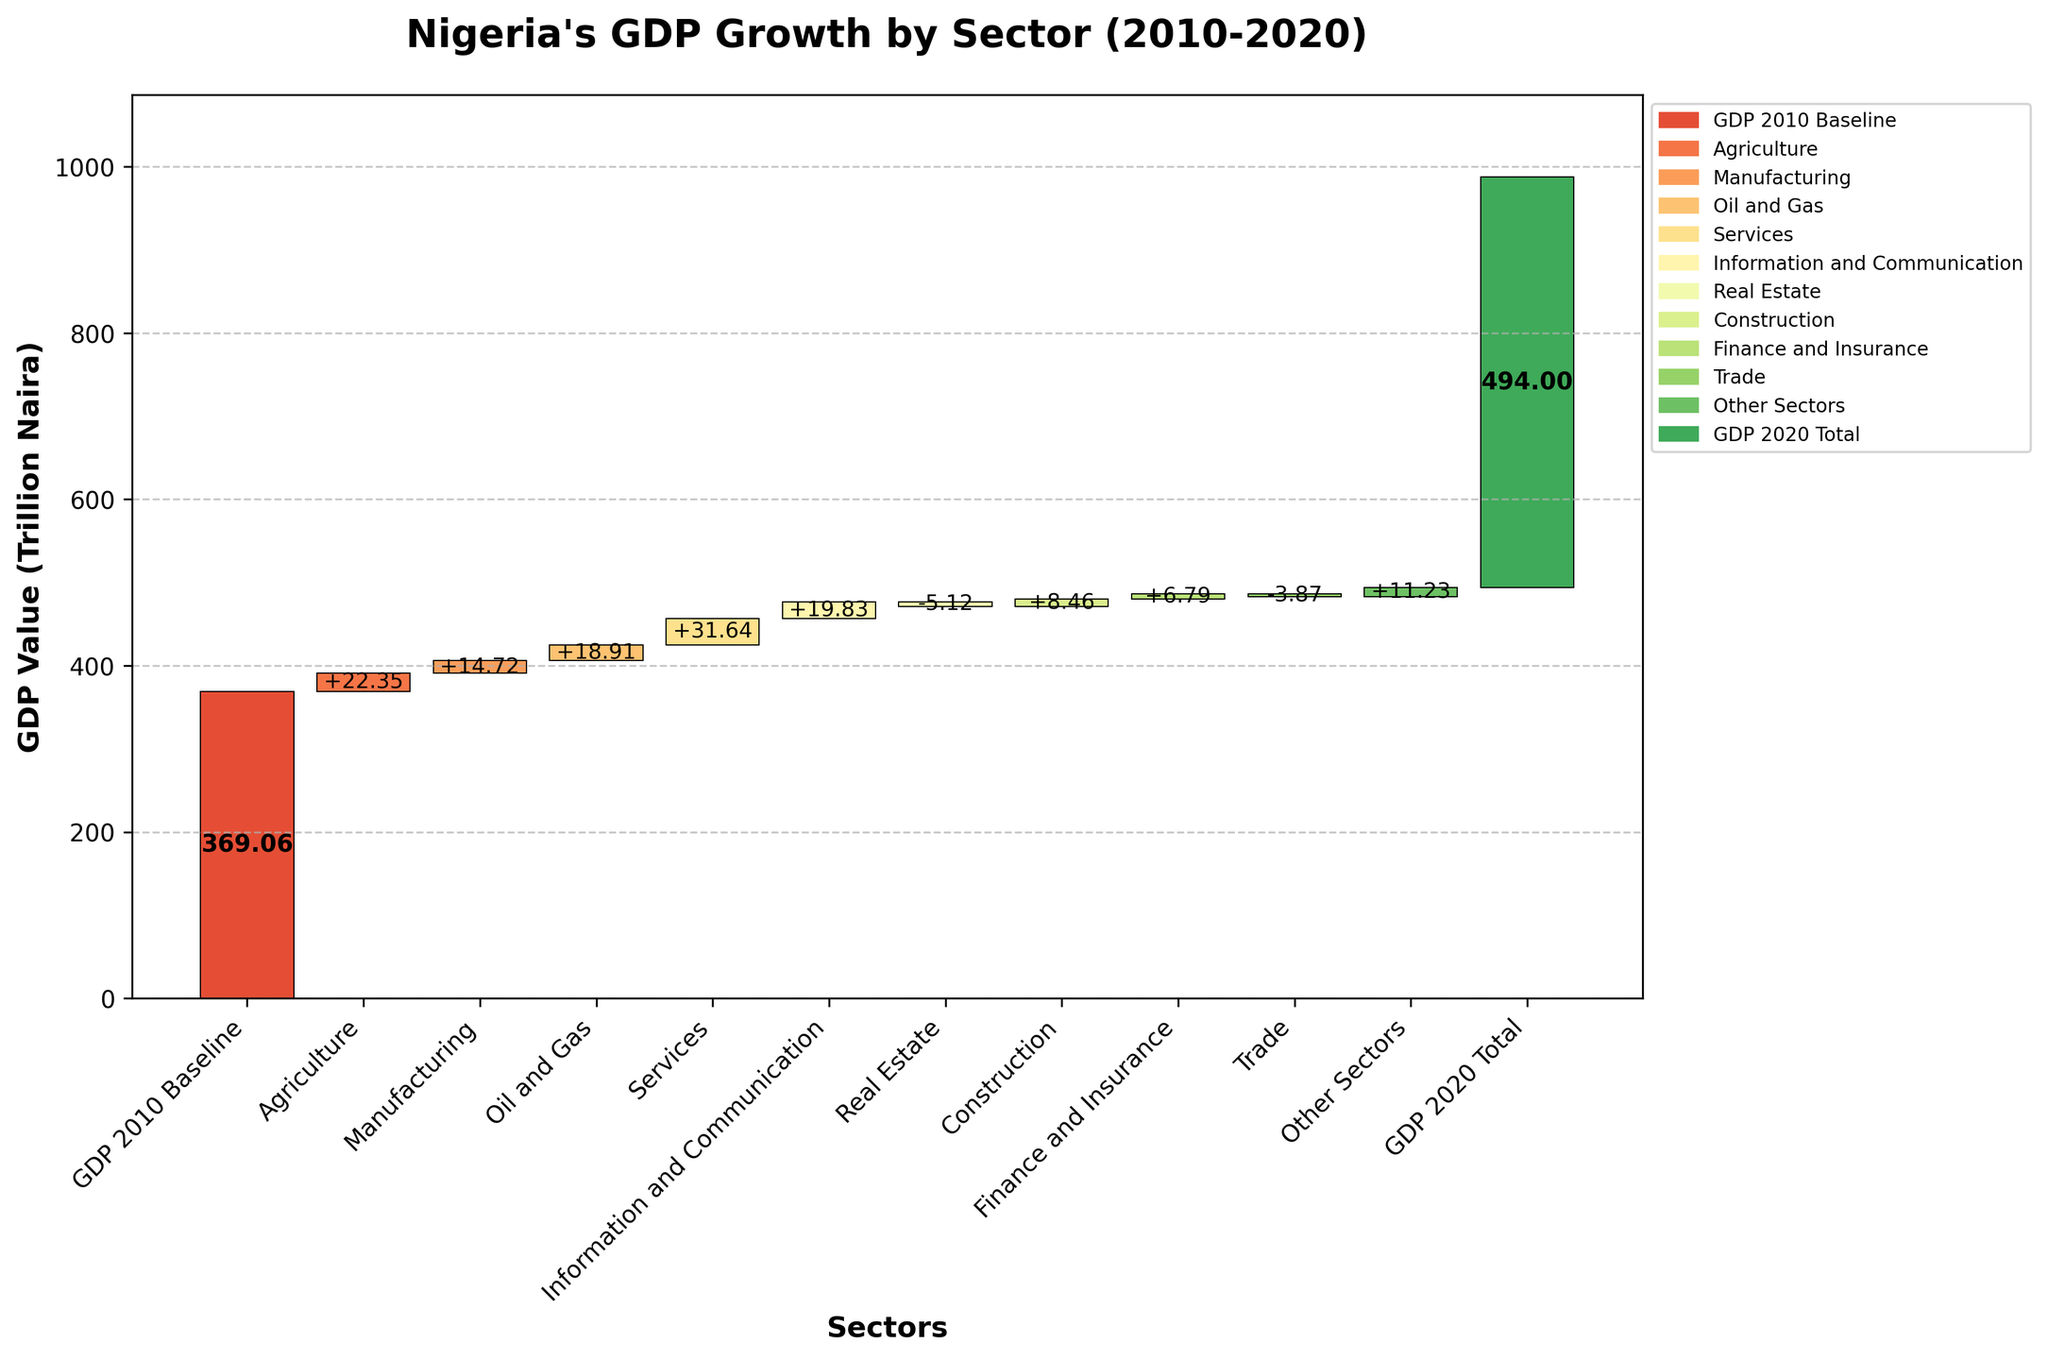What is the title of the chart? The title of the chart is usually found at the top of the figure and indicates what the chart is about. In this case, the title is centered at the top.
Answer: Nigeria's GDP Growth by Sector (2010-2020) Which sector contributed the most to Nigeria's GDP growth from 2010 to 2020? To find the sector that contributed the most, look at the bar with the largest positive value.
Answer: Services How did the Real Estate sector affect Nigeria's GDP from 2010 to 2020? Check the label and direction of the bar corresponding to the Real Estate sector. Negative values indicate a negative contribution.
Answer: It decreased the GDP by 5.12 trillion Naira Compare the contributions of Oil and Gas and Information and Communication sectors to Nigeria's GDP. Which one is higher? Look at the bars for both sectors and compare their heights and values.
Answer: Information and Communication is higher (19.83 vs 18.91) What is the cumulative GDP value after taking into account the Agriculture sector? To find this, add the value of the baseline GDP and the value contributed by Agriculture.
Answer: 391.41 trillion Naira What was the GDP in 2020 compared to 2010? Look at the bar representing 'GDP 2020 Total' and compare it to 'GDP 2010 Baseline'.
Answer: 124.94 trillion Naira higher How many sectors had a negative impact on Nigeria's GDP growth? Count the bars that point downwards and have negative values.
Answer: 2 sectors (Real Estate and Trade) Which sector had the smallest positive contribution to Nigeria's GDP? Look for the smallest positive value among the bars.
Answer: Finance and Insurance (6.79) What is the net change in GDP contributed by Trade and Real Estate sectors combined? Add the values for Trade and Real Estate which are both negative in this case.
Answer: -8.99 trillion Naira How did the Construction sector contribute to Nigeria's GDP? Check the label and value of the bar corresponding to Construction. Positive values indicate a positive contribution.
Answer: It increased the GDP by 8.46 trillion Naira 